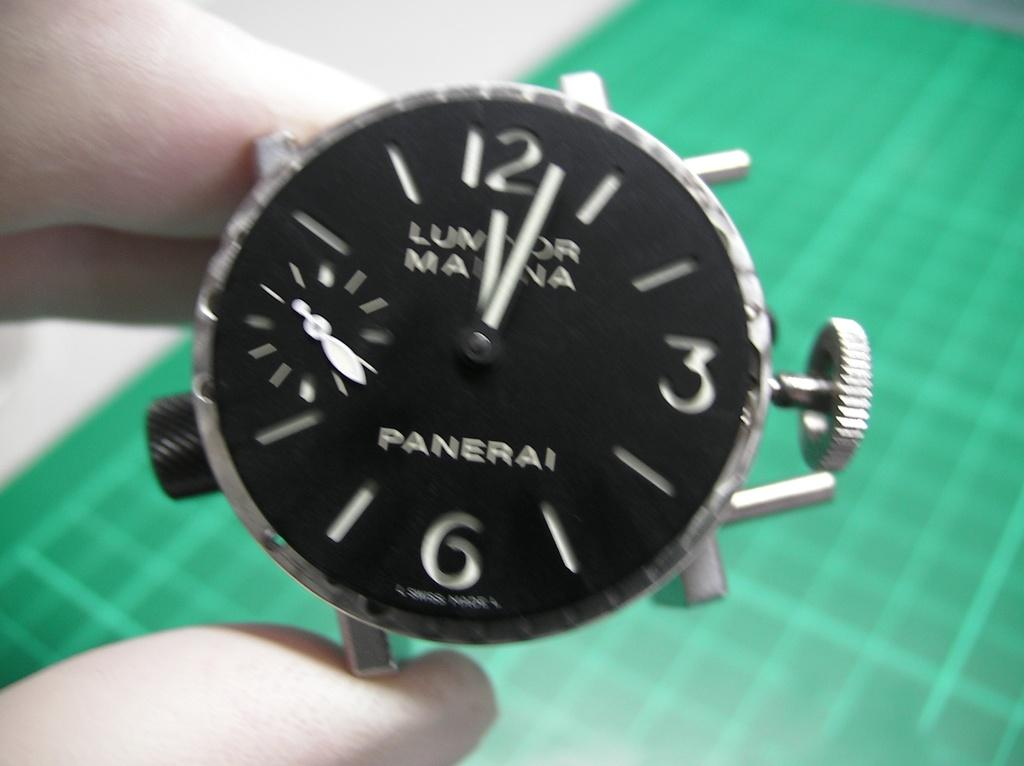<image>
Summarize the visual content of the image. Someone holds a watch face by Panerai over a green grid table. 